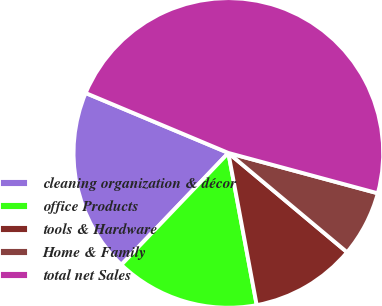Convert chart to OTSL. <chart><loc_0><loc_0><loc_500><loc_500><pie_chart><fcel>cleaning organization & décor<fcel>office Products<fcel>tools & Hardware<fcel>Home & Family<fcel>total net Sales<nl><fcel>19.18%<fcel>15.08%<fcel>10.98%<fcel>6.89%<fcel>47.87%<nl></chart> 